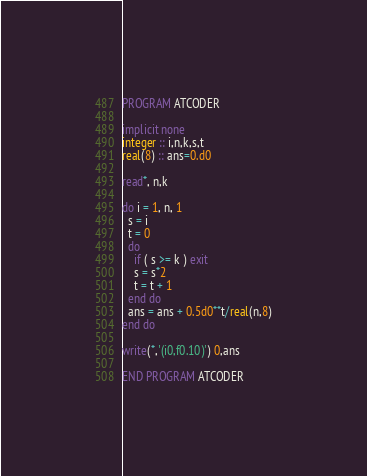<code> <loc_0><loc_0><loc_500><loc_500><_FORTRAN_>PROGRAM ATCODER

implicit none
integer :: i,n,k,s,t
real(8) :: ans=0.d0

read*, n,k

do i = 1, n, 1
  s = i
  t = 0
  do
    if ( s >= k ) exit
    s = s*2
    t = t + 1
  end do
  ans = ans + 0.5d0**t/real(n,8)
end do

write(*,'(i0,f0.10)') 0,ans

END PROGRAM ATCODER</code> 